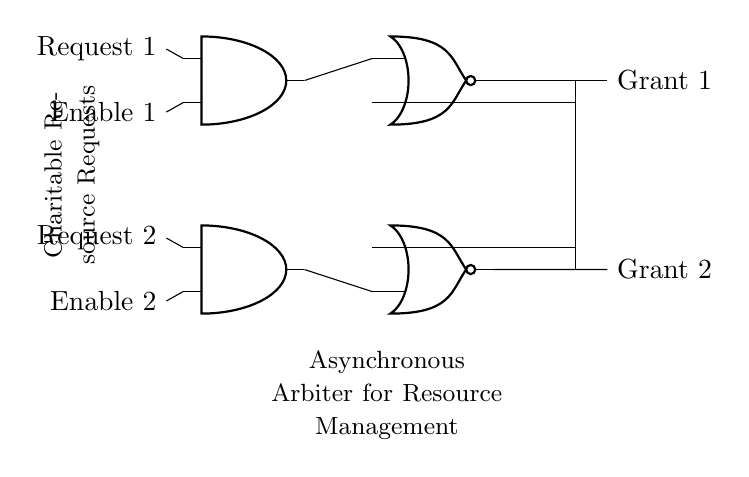What are the main components in this circuit? The main components visible in the circuit are two AND gates and two NOR gates. The AND gates are responsible for processing requests and enabling signals, while the NOR gates control the grant outputs based on the inputs from the AND gates.
Answer: AND gates, NOR gates How many request inputs does the arbiter circuit have? The arbiter circuit has two request inputs labeled as Request 1 and Request 2. Each request input corresponds to a separate AND gate, which evaluates the requests for resource access.
Answer: Two What is the purpose of the Enable signals in this circuit? The Enable signals are inputs to the AND gates that allow or deny the processing of the corresponding request inputs. If an Enable signal is activated, the associated request can be processed; otherwise, the request output will be inactive.
Answer: Allow processing How do the outputs Grant 1 and Grant 2 relate to requests? The outputs Grant 1 and Grant 2 indicate whether the corresponding request (Request 1 or Request 2) has been granted access to the shared resource. If a request is valid and enabled, one of the outputs will be activated based on the NOR gate logic.
Answer: Grant access What type of circuit is represented here? This circuit is an asynchronous arbiter, which manages access to shared resources without relying on a global clock signal. It allows various requests to be handled simultaneously while preventing conflicts.
Answer: Asynchronous arbiter Which logic gates are responsible for the granting operations? The NOR gates are responsible for determining the grant operations. They take the output from the AND gates and manage the signal distribution to ensure only one grant is activated at any time for the shared resources.
Answer: NOR gates 